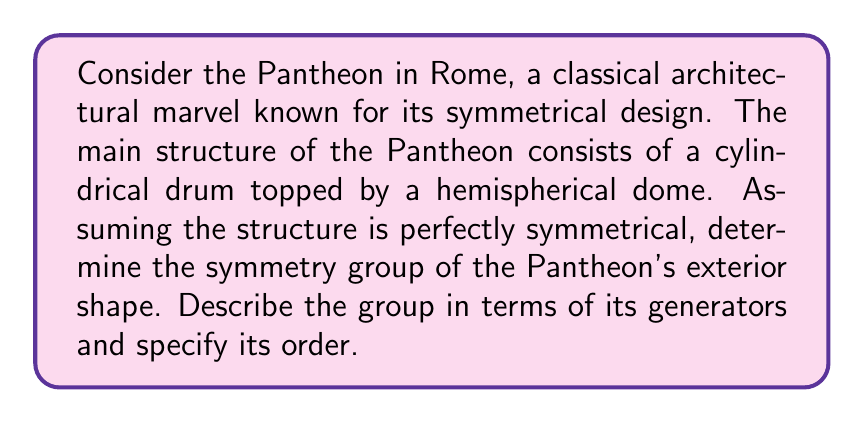Show me your answer to this math problem. To determine the symmetry group of the Pantheon's exterior shape, we need to consider the symmetries of a cylinder combined with those of a hemisphere:

1. Rotational symmetry:
   - The cylindrical drum has infinite rotational symmetry around its vertical axis.
   - The hemispherical dome adds no additional rotational symmetry.

2. Reflectional symmetry:
   - There are infinite vertical planes of reflection passing through the central axis.
   - There is one horizontal plane of reflection at the base of the hemisphere.

3. Inversion symmetry:
   - The structure does not have inversion symmetry due to the hemisphere.

The symmetry group of the Pantheon's exterior can be described as follows:

- Let $R_\theta$ represent a rotation by angle $\theta$ around the vertical axis.
- Let $M_\phi$ represent a reflection in a vertical plane at angle $\phi$ to a fixed reference plane.
- Let $H$ represent the reflection in the horizontal plane.

The group generators are:
1. $R_\theta$ for any $\theta \in \mathbb{R}$
2. $M_0$ (reflection in a fixed vertical plane)
3. $H$ (horizontal reflection)

The group operation is composition of transformations.

This group is isomorphic to $O(2) \times \mathbb{Z}_2$, where:
- $O(2)$ is the orthogonal group in 2 dimensions, representing the rotations and reflections around the vertical axis.
- $\mathbb{Z}_2$ represents the horizontal reflection (or its absence).

The order of this group is infinite due to the continuous rotational symmetry.
Answer: The symmetry group of the Pantheon's exterior is isomorphic to $O(2) \times \mathbb{Z}_2$, generated by $\{R_\theta, M_0, H\}$, where $R_\theta$ represents rotations, $M_0$ vertical reflections, and $H$ horizontal reflection. The group has infinite order. 